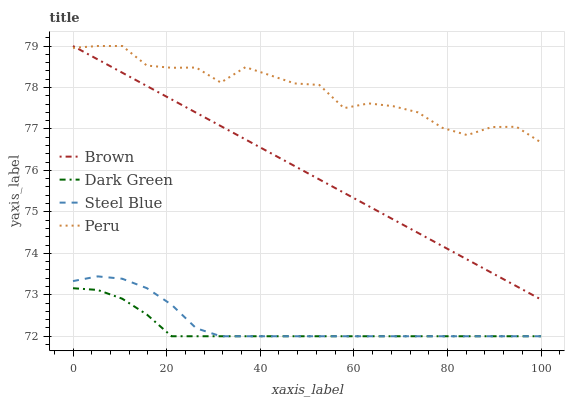Does Dark Green have the minimum area under the curve?
Answer yes or no. Yes. Does Peru have the maximum area under the curve?
Answer yes or no. Yes. Does Steel Blue have the minimum area under the curve?
Answer yes or no. No. Does Steel Blue have the maximum area under the curve?
Answer yes or no. No. Is Brown the smoothest?
Answer yes or no. Yes. Is Peru the roughest?
Answer yes or no. Yes. Is Steel Blue the smoothest?
Answer yes or no. No. Is Steel Blue the roughest?
Answer yes or no. No. Does Peru have the lowest value?
Answer yes or no. No. Does Steel Blue have the highest value?
Answer yes or no. No. Is Steel Blue less than Peru?
Answer yes or no. Yes. Is Brown greater than Dark Green?
Answer yes or no. Yes. Does Steel Blue intersect Peru?
Answer yes or no. No. 